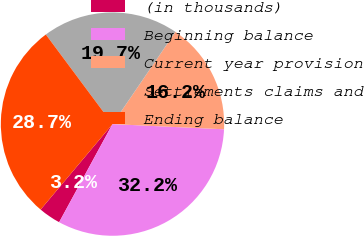Convert chart to OTSL. <chart><loc_0><loc_0><loc_500><loc_500><pie_chart><fcel>(in thousands)<fcel>Beginning balance<fcel>Current year provision<fcel>Settlements claims and<fcel>Ending balance<nl><fcel>3.2%<fcel>32.19%<fcel>16.21%<fcel>19.71%<fcel>28.69%<nl></chart> 